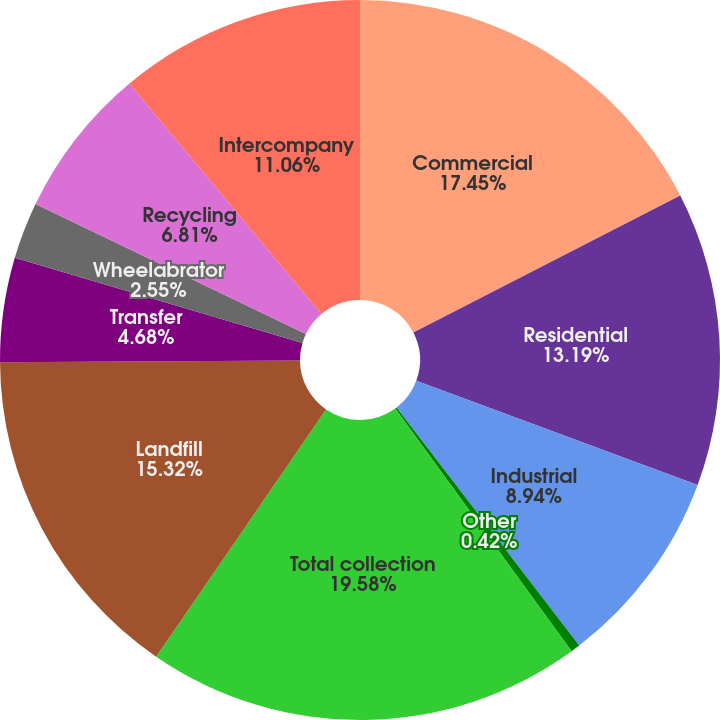<chart> <loc_0><loc_0><loc_500><loc_500><pie_chart><fcel>Commercial<fcel>Residential<fcel>Industrial<fcel>Other<fcel>Total collection<fcel>Landfill<fcel>Transfer<fcel>Wheelabrator<fcel>Recycling<fcel>Intercompany<nl><fcel>17.45%<fcel>13.19%<fcel>8.94%<fcel>0.42%<fcel>19.58%<fcel>15.32%<fcel>4.68%<fcel>2.55%<fcel>6.81%<fcel>11.06%<nl></chart> 